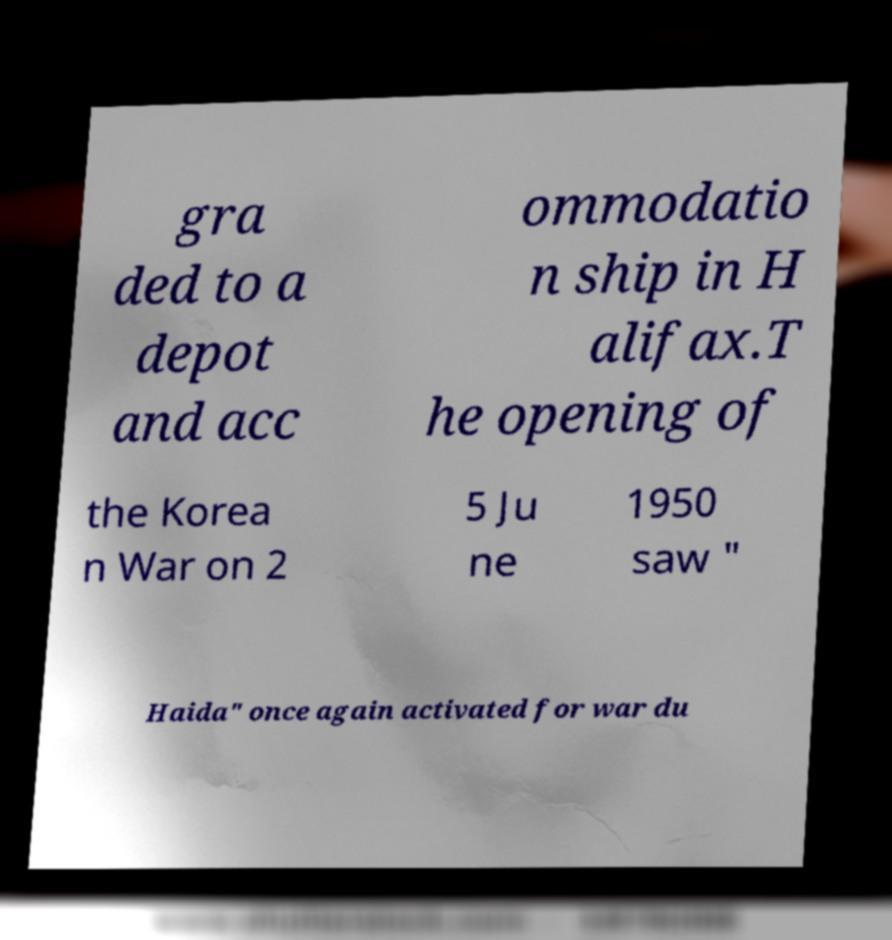For documentation purposes, I need the text within this image transcribed. Could you provide that? gra ded to a depot and acc ommodatio n ship in H alifax.T he opening of the Korea n War on 2 5 Ju ne 1950 saw " Haida" once again activated for war du 